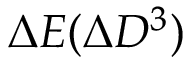Convert formula to latex. <formula><loc_0><loc_0><loc_500><loc_500>\Delta E ( \Delta D ^ { 3 } )</formula> 